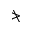<formula> <loc_0><loc_0><loc_500><loc_500>\ngtr</formula> 